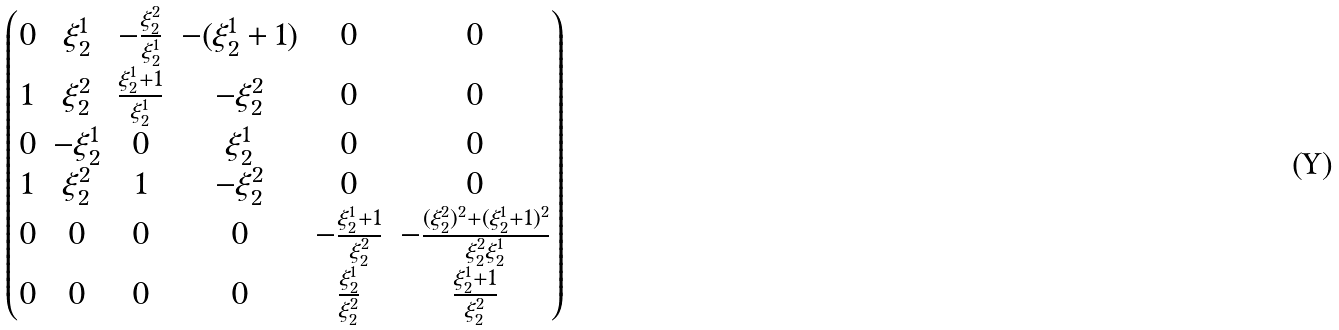Convert formula to latex. <formula><loc_0><loc_0><loc_500><loc_500>\begin{pmatrix} 0 & \xi ^ { 1 } _ { 2 } & - \frac { \xi ^ { 2 } _ { 2 } } { \xi ^ { 1 } _ { 2 } } & - ( \xi ^ { 1 } _ { 2 } + 1 ) & 0 & 0 \\ 1 & \xi ^ { 2 } _ { 2 } & \frac { \xi ^ { 1 } _ { 2 } + 1 } { \xi ^ { 1 } _ { 2 } } & - \xi ^ { 2 } _ { 2 } & 0 & 0 \\ 0 & - \xi ^ { 1 } _ { 2 } & 0 & \xi ^ { 1 } _ { 2 } & 0 & 0 \\ 1 & \xi ^ { 2 } _ { 2 } & 1 & - \xi ^ { 2 } _ { 2 } & 0 & 0 \\ 0 & 0 & 0 & 0 & - \frac { \xi ^ { 1 } _ { 2 } + 1 } { \xi ^ { 2 } _ { 2 } } & - \frac { ( \xi ^ { 2 } _ { 2 } ) ^ { 2 } + ( \xi ^ { 1 } _ { 2 } + 1 ) ^ { 2 } } { \xi ^ { 2 } _ { 2 } \xi ^ { 1 } _ { 2 } } \\ 0 & 0 & 0 & 0 & \frac { \xi ^ { 1 } _ { 2 } } { \xi ^ { 2 } _ { 2 } } & \frac { \xi ^ { 1 } _ { 2 } + 1 } { \xi ^ { 2 } _ { 2 } } \end{pmatrix}</formula> 